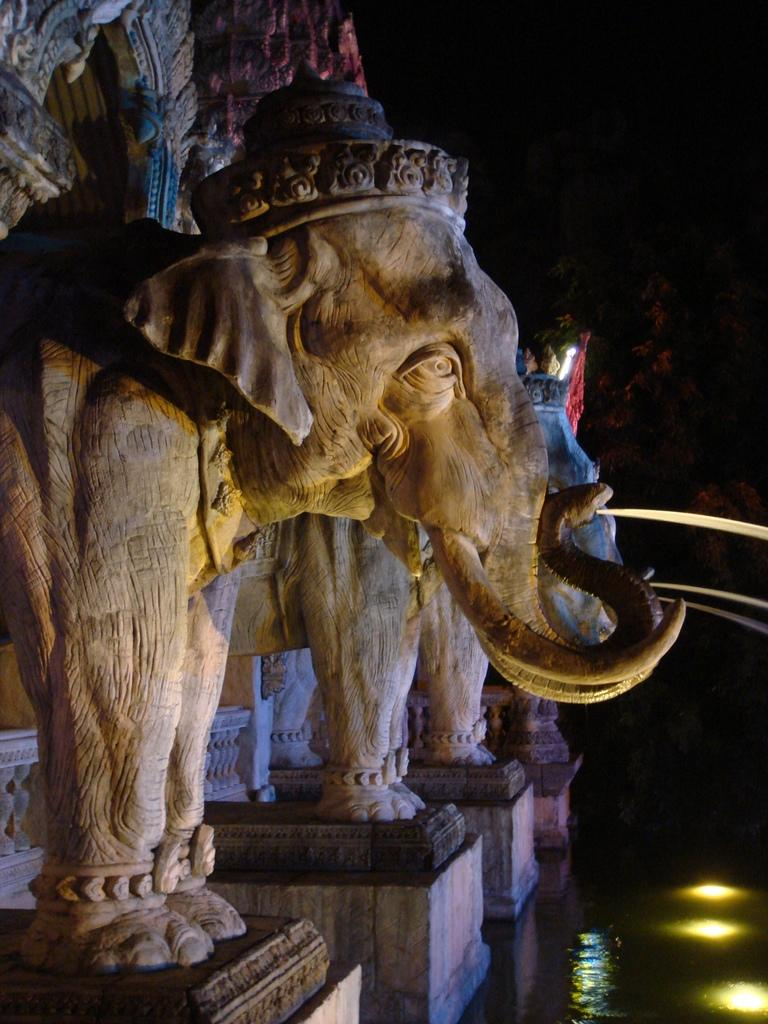What is the main subject of the image? There is an elephant-shaped sculpture in the image. What architectural feature can be seen at the top of the image? There is an arch at the top of the image. What natural element is visible at the bottom of the image? There is water visible at the bottom of the image. What type of plough is being used to cultivate the land in the image? There is no plough present in the image. The image features an elephant-shaped sculpture, an arch, and water, but no farming equipment or cultivation activities are depicted. 